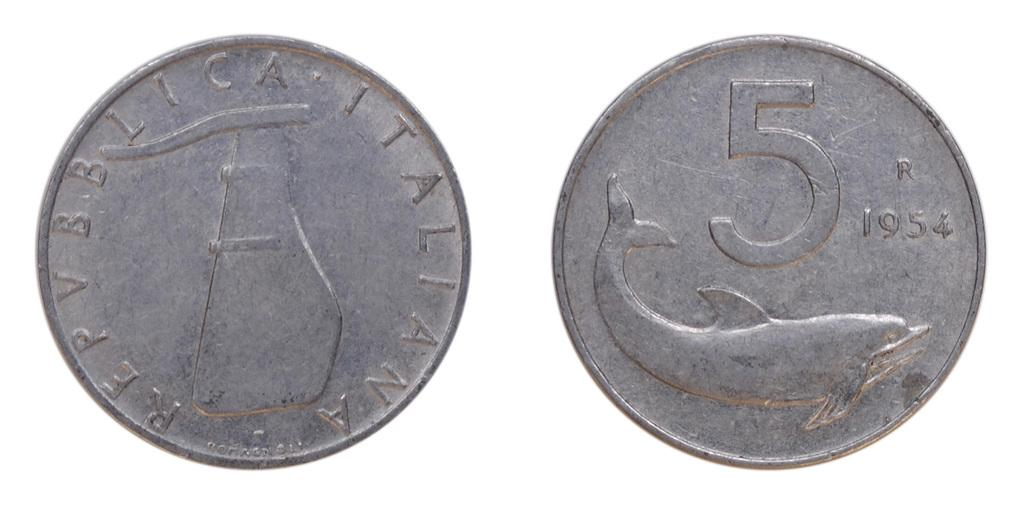<image>
Give a short and clear explanation of the subsequent image. A coin from Republica Italia that has a picture of a dolphin and the number 5. 